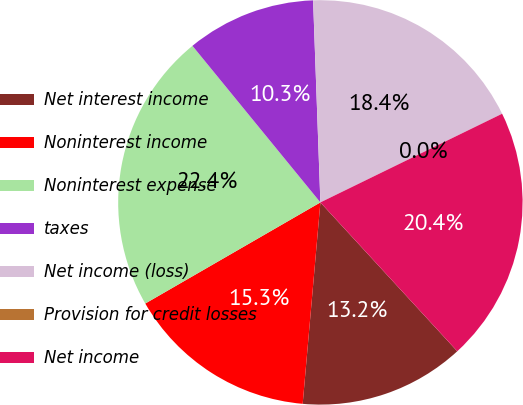Convert chart. <chart><loc_0><loc_0><loc_500><loc_500><pie_chart><fcel>Net interest income<fcel>Noninterest income<fcel>Noninterest expense<fcel>taxes<fcel>Net income (loss)<fcel>Provision for credit losses<fcel>Net income<nl><fcel>13.23%<fcel>15.27%<fcel>22.43%<fcel>10.33%<fcel>18.35%<fcel>0.0%<fcel>20.39%<nl></chart> 